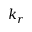<formula> <loc_0><loc_0><loc_500><loc_500>k _ { r }</formula> 